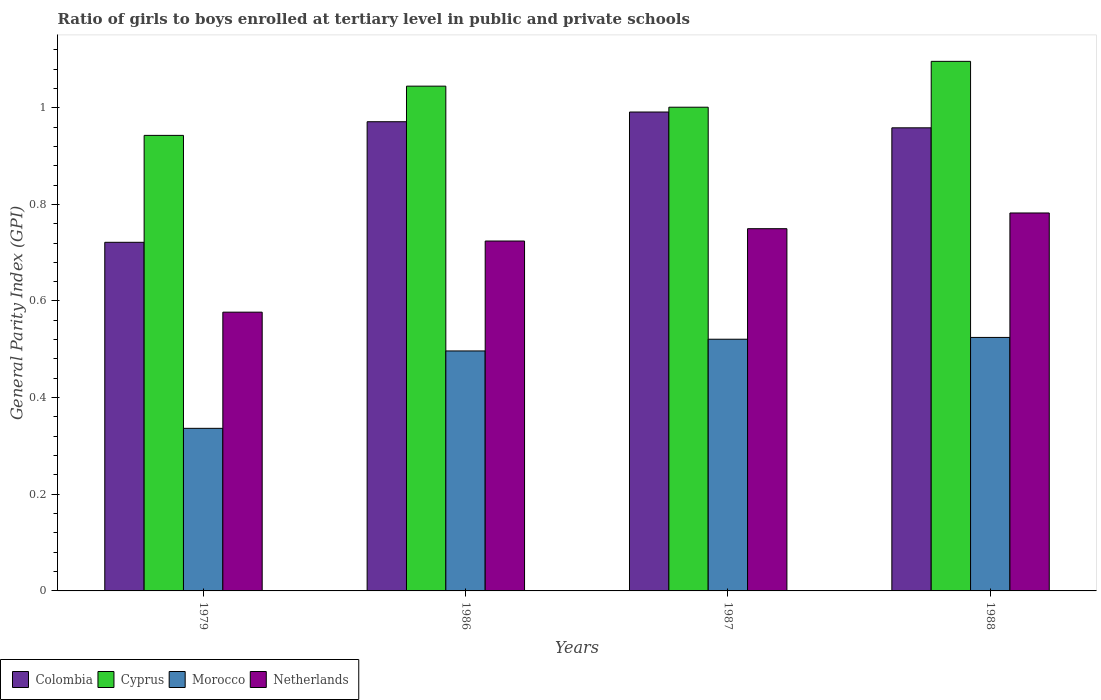How many bars are there on the 2nd tick from the left?
Provide a short and direct response. 4. How many bars are there on the 1st tick from the right?
Ensure brevity in your answer.  4. What is the general parity index in Netherlands in 1987?
Give a very brief answer. 0.75. Across all years, what is the maximum general parity index in Colombia?
Your response must be concise. 0.99. Across all years, what is the minimum general parity index in Netherlands?
Ensure brevity in your answer.  0.58. In which year was the general parity index in Colombia minimum?
Keep it short and to the point. 1979. What is the total general parity index in Cyprus in the graph?
Give a very brief answer. 4.08. What is the difference between the general parity index in Netherlands in 1987 and that in 1988?
Offer a very short reply. -0.03. What is the difference between the general parity index in Colombia in 1986 and the general parity index in Netherlands in 1987?
Keep it short and to the point. 0.22. What is the average general parity index in Morocco per year?
Offer a very short reply. 0.47. In the year 1986, what is the difference between the general parity index in Netherlands and general parity index in Cyprus?
Offer a terse response. -0.32. What is the ratio of the general parity index in Morocco in 1979 to that in 1986?
Offer a very short reply. 0.68. Is the general parity index in Morocco in 1986 less than that in 1988?
Your answer should be compact. Yes. What is the difference between the highest and the second highest general parity index in Netherlands?
Your answer should be very brief. 0.03. What is the difference between the highest and the lowest general parity index in Netherlands?
Your answer should be compact. 0.21. In how many years, is the general parity index in Netherlands greater than the average general parity index in Netherlands taken over all years?
Give a very brief answer. 3. Is the sum of the general parity index in Colombia in 1979 and 1988 greater than the maximum general parity index in Cyprus across all years?
Give a very brief answer. Yes. Is it the case that in every year, the sum of the general parity index in Morocco and general parity index in Netherlands is greater than the sum of general parity index in Colombia and general parity index in Cyprus?
Your response must be concise. No. What does the 2nd bar from the left in 1986 represents?
Your answer should be very brief. Cyprus. What does the 3rd bar from the right in 1988 represents?
Your response must be concise. Cyprus. How many bars are there?
Offer a very short reply. 16. What is the difference between two consecutive major ticks on the Y-axis?
Keep it short and to the point. 0.2. Does the graph contain grids?
Your answer should be very brief. No. How many legend labels are there?
Offer a very short reply. 4. How are the legend labels stacked?
Ensure brevity in your answer.  Horizontal. What is the title of the graph?
Your answer should be compact. Ratio of girls to boys enrolled at tertiary level in public and private schools. Does "Madagascar" appear as one of the legend labels in the graph?
Offer a very short reply. No. What is the label or title of the Y-axis?
Your answer should be very brief. General Parity Index (GPI). What is the General Parity Index (GPI) of Colombia in 1979?
Keep it short and to the point. 0.72. What is the General Parity Index (GPI) in Cyprus in 1979?
Your answer should be very brief. 0.94. What is the General Parity Index (GPI) of Morocco in 1979?
Provide a short and direct response. 0.34. What is the General Parity Index (GPI) in Netherlands in 1979?
Provide a short and direct response. 0.58. What is the General Parity Index (GPI) of Colombia in 1986?
Provide a short and direct response. 0.97. What is the General Parity Index (GPI) of Cyprus in 1986?
Provide a short and direct response. 1.04. What is the General Parity Index (GPI) of Morocco in 1986?
Provide a short and direct response. 0.5. What is the General Parity Index (GPI) in Netherlands in 1986?
Provide a succinct answer. 0.72. What is the General Parity Index (GPI) of Colombia in 1987?
Offer a very short reply. 0.99. What is the General Parity Index (GPI) of Cyprus in 1987?
Give a very brief answer. 1. What is the General Parity Index (GPI) of Morocco in 1987?
Your answer should be very brief. 0.52. What is the General Parity Index (GPI) in Netherlands in 1987?
Your answer should be very brief. 0.75. What is the General Parity Index (GPI) in Colombia in 1988?
Ensure brevity in your answer.  0.96. What is the General Parity Index (GPI) in Cyprus in 1988?
Offer a very short reply. 1.1. What is the General Parity Index (GPI) in Morocco in 1988?
Make the answer very short. 0.52. What is the General Parity Index (GPI) in Netherlands in 1988?
Your answer should be very brief. 0.78. Across all years, what is the maximum General Parity Index (GPI) in Colombia?
Make the answer very short. 0.99. Across all years, what is the maximum General Parity Index (GPI) in Cyprus?
Provide a succinct answer. 1.1. Across all years, what is the maximum General Parity Index (GPI) of Morocco?
Your response must be concise. 0.52. Across all years, what is the maximum General Parity Index (GPI) of Netherlands?
Your answer should be very brief. 0.78. Across all years, what is the minimum General Parity Index (GPI) of Colombia?
Offer a terse response. 0.72. Across all years, what is the minimum General Parity Index (GPI) of Cyprus?
Ensure brevity in your answer.  0.94. Across all years, what is the minimum General Parity Index (GPI) in Morocco?
Keep it short and to the point. 0.34. Across all years, what is the minimum General Parity Index (GPI) in Netherlands?
Your response must be concise. 0.58. What is the total General Parity Index (GPI) of Colombia in the graph?
Provide a succinct answer. 3.64. What is the total General Parity Index (GPI) of Cyprus in the graph?
Ensure brevity in your answer.  4.08. What is the total General Parity Index (GPI) of Morocco in the graph?
Your response must be concise. 1.88. What is the total General Parity Index (GPI) of Netherlands in the graph?
Provide a short and direct response. 2.83. What is the difference between the General Parity Index (GPI) of Colombia in 1979 and that in 1986?
Your response must be concise. -0.25. What is the difference between the General Parity Index (GPI) in Cyprus in 1979 and that in 1986?
Your response must be concise. -0.1. What is the difference between the General Parity Index (GPI) of Morocco in 1979 and that in 1986?
Provide a short and direct response. -0.16. What is the difference between the General Parity Index (GPI) in Netherlands in 1979 and that in 1986?
Keep it short and to the point. -0.15. What is the difference between the General Parity Index (GPI) of Colombia in 1979 and that in 1987?
Provide a short and direct response. -0.27. What is the difference between the General Parity Index (GPI) of Cyprus in 1979 and that in 1987?
Give a very brief answer. -0.06. What is the difference between the General Parity Index (GPI) of Morocco in 1979 and that in 1987?
Your answer should be compact. -0.18. What is the difference between the General Parity Index (GPI) in Netherlands in 1979 and that in 1987?
Your answer should be compact. -0.17. What is the difference between the General Parity Index (GPI) in Colombia in 1979 and that in 1988?
Your answer should be compact. -0.24. What is the difference between the General Parity Index (GPI) of Cyprus in 1979 and that in 1988?
Keep it short and to the point. -0.15. What is the difference between the General Parity Index (GPI) in Morocco in 1979 and that in 1988?
Provide a succinct answer. -0.19. What is the difference between the General Parity Index (GPI) in Netherlands in 1979 and that in 1988?
Your answer should be compact. -0.21. What is the difference between the General Parity Index (GPI) of Colombia in 1986 and that in 1987?
Ensure brevity in your answer.  -0.02. What is the difference between the General Parity Index (GPI) of Cyprus in 1986 and that in 1987?
Give a very brief answer. 0.04. What is the difference between the General Parity Index (GPI) in Morocco in 1986 and that in 1987?
Provide a short and direct response. -0.02. What is the difference between the General Parity Index (GPI) of Netherlands in 1986 and that in 1987?
Make the answer very short. -0.03. What is the difference between the General Parity Index (GPI) of Colombia in 1986 and that in 1988?
Provide a succinct answer. 0.01. What is the difference between the General Parity Index (GPI) of Cyprus in 1986 and that in 1988?
Offer a very short reply. -0.05. What is the difference between the General Parity Index (GPI) in Morocco in 1986 and that in 1988?
Provide a short and direct response. -0.03. What is the difference between the General Parity Index (GPI) of Netherlands in 1986 and that in 1988?
Give a very brief answer. -0.06. What is the difference between the General Parity Index (GPI) of Colombia in 1987 and that in 1988?
Make the answer very short. 0.03. What is the difference between the General Parity Index (GPI) in Cyprus in 1987 and that in 1988?
Provide a succinct answer. -0.09. What is the difference between the General Parity Index (GPI) in Morocco in 1987 and that in 1988?
Your response must be concise. -0. What is the difference between the General Parity Index (GPI) of Netherlands in 1987 and that in 1988?
Give a very brief answer. -0.03. What is the difference between the General Parity Index (GPI) of Colombia in 1979 and the General Parity Index (GPI) of Cyprus in 1986?
Keep it short and to the point. -0.32. What is the difference between the General Parity Index (GPI) in Colombia in 1979 and the General Parity Index (GPI) in Morocco in 1986?
Your answer should be very brief. 0.22. What is the difference between the General Parity Index (GPI) in Colombia in 1979 and the General Parity Index (GPI) in Netherlands in 1986?
Your answer should be very brief. -0. What is the difference between the General Parity Index (GPI) in Cyprus in 1979 and the General Parity Index (GPI) in Morocco in 1986?
Provide a short and direct response. 0.45. What is the difference between the General Parity Index (GPI) of Cyprus in 1979 and the General Parity Index (GPI) of Netherlands in 1986?
Give a very brief answer. 0.22. What is the difference between the General Parity Index (GPI) of Morocco in 1979 and the General Parity Index (GPI) of Netherlands in 1986?
Offer a terse response. -0.39. What is the difference between the General Parity Index (GPI) in Colombia in 1979 and the General Parity Index (GPI) in Cyprus in 1987?
Your answer should be compact. -0.28. What is the difference between the General Parity Index (GPI) in Colombia in 1979 and the General Parity Index (GPI) in Morocco in 1987?
Your response must be concise. 0.2. What is the difference between the General Parity Index (GPI) in Colombia in 1979 and the General Parity Index (GPI) in Netherlands in 1987?
Make the answer very short. -0.03. What is the difference between the General Parity Index (GPI) in Cyprus in 1979 and the General Parity Index (GPI) in Morocco in 1987?
Give a very brief answer. 0.42. What is the difference between the General Parity Index (GPI) of Cyprus in 1979 and the General Parity Index (GPI) of Netherlands in 1987?
Provide a short and direct response. 0.19. What is the difference between the General Parity Index (GPI) in Morocco in 1979 and the General Parity Index (GPI) in Netherlands in 1987?
Your answer should be compact. -0.41. What is the difference between the General Parity Index (GPI) of Colombia in 1979 and the General Parity Index (GPI) of Cyprus in 1988?
Your response must be concise. -0.37. What is the difference between the General Parity Index (GPI) of Colombia in 1979 and the General Parity Index (GPI) of Morocco in 1988?
Give a very brief answer. 0.2. What is the difference between the General Parity Index (GPI) of Colombia in 1979 and the General Parity Index (GPI) of Netherlands in 1988?
Make the answer very short. -0.06. What is the difference between the General Parity Index (GPI) of Cyprus in 1979 and the General Parity Index (GPI) of Morocco in 1988?
Make the answer very short. 0.42. What is the difference between the General Parity Index (GPI) of Cyprus in 1979 and the General Parity Index (GPI) of Netherlands in 1988?
Your response must be concise. 0.16. What is the difference between the General Parity Index (GPI) of Morocco in 1979 and the General Parity Index (GPI) of Netherlands in 1988?
Your response must be concise. -0.45. What is the difference between the General Parity Index (GPI) of Colombia in 1986 and the General Parity Index (GPI) of Cyprus in 1987?
Provide a short and direct response. -0.03. What is the difference between the General Parity Index (GPI) in Colombia in 1986 and the General Parity Index (GPI) in Morocco in 1987?
Keep it short and to the point. 0.45. What is the difference between the General Parity Index (GPI) in Colombia in 1986 and the General Parity Index (GPI) in Netherlands in 1987?
Provide a short and direct response. 0.22. What is the difference between the General Parity Index (GPI) in Cyprus in 1986 and the General Parity Index (GPI) in Morocco in 1987?
Your answer should be compact. 0.52. What is the difference between the General Parity Index (GPI) in Cyprus in 1986 and the General Parity Index (GPI) in Netherlands in 1987?
Offer a very short reply. 0.29. What is the difference between the General Parity Index (GPI) of Morocco in 1986 and the General Parity Index (GPI) of Netherlands in 1987?
Your answer should be very brief. -0.25. What is the difference between the General Parity Index (GPI) of Colombia in 1986 and the General Parity Index (GPI) of Cyprus in 1988?
Ensure brevity in your answer.  -0.12. What is the difference between the General Parity Index (GPI) of Colombia in 1986 and the General Parity Index (GPI) of Morocco in 1988?
Provide a short and direct response. 0.45. What is the difference between the General Parity Index (GPI) in Colombia in 1986 and the General Parity Index (GPI) in Netherlands in 1988?
Make the answer very short. 0.19. What is the difference between the General Parity Index (GPI) in Cyprus in 1986 and the General Parity Index (GPI) in Morocco in 1988?
Offer a very short reply. 0.52. What is the difference between the General Parity Index (GPI) in Cyprus in 1986 and the General Parity Index (GPI) in Netherlands in 1988?
Offer a very short reply. 0.26. What is the difference between the General Parity Index (GPI) in Morocco in 1986 and the General Parity Index (GPI) in Netherlands in 1988?
Provide a short and direct response. -0.29. What is the difference between the General Parity Index (GPI) in Colombia in 1987 and the General Parity Index (GPI) in Cyprus in 1988?
Give a very brief answer. -0.1. What is the difference between the General Parity Index (GPI) of Colombia in 1987 and the General Parity Index (GPI) of Morocco in 1988?
Provide a short and direct response. 0.47. What is the difference between the General Parity Index (GPI) in Colombia in 1987 and the General Parity Index (GPI) in Netherlands in 1988?
Offer a very short reply. 0.21. What is the difference between the General Parity Index (GPI) in Cyprus in 1987 and the General Parity Index (GPI) in Morocco in 1988?
Your response must be concise. 0.48. What is the difference between the General Parity Index (GPI) in Cyprus in 1987 and the General Parity Index (GPI) in Netherlands in 1988?
Your answer should be compact. 0.22. What is the difference between the General Parity Index (GPI) in Morocco in 1987 and the General Parity Index (GPI) in Netherlands in 1988?
Offer a very short reply. -0.26. What is the average General Parity Index (GPI) in Colombia per year?
Your response must be concise. 0.91. What is the average General Parity Index (GPI) in Cyprus per year?
Your answer should be very brief. 1.02. What is the average General Parity Index (GPI) in Morocco per year?
Provide a succinct answer. 0.47. What is the average General Parity Index (GPI) in Netherlands per year?
Provide a short and direct response. 0.71. In the year 1979, what is the difference between the General Parity Index (GPI) of Colombia and General Parity Index (GPI) of Cyprus?
Ensure brevity in your answer.  -0.22. In the year 1979, what is the difference between the General Parity Index (GPI) of Colombia and General Parity Index (GPI) of Morocco?
Keep it short and to the point. 0.39. In the year 1979, what is the difference between the General Parity Index (GPI) in Colombia and General Parity Index (GPI) in Netherlands?
Provide a short and direct response. 0.14. In the year 1979, what is the difference between the General Parity Index (GPI) of Cyprus and General Parity Index (GPI) of Morocco?
Provide a succinct answer. 0.61. In the year 1979, what is the difference between the General Parity Index (GPI) of Cyprus and General Parity Index (GPI) of Netherlands?
Offer a very short reply. 0.37. In the year 1979, what is the difference between the General Parity Index (GPI) in Morocco and General Parity Index (GPI) in Netherlands?
Give a very brief answer. -0.24. In the year 1986, what is the difference between the General Parity Index (GPI) of Colombia and General Parity Index (GPI) of Cyprus?
Give a very brief answer. -0.07. In the year 1986, what is the difference between the General Parity Index (GPI) of Colombia and General Parity Index (GPI) of Morocco?
Ensure brevity in your answer.  0.47. In the year 1986, what is the difference between the General Parity Index (GPI) in Colombia and General Parity Index (GPI) in Netherlands?
Give a very brief answer. 0.25. In the year 1986, what is the difference between the General Parity Index (GPI) of Cyprus and General Parity Index (GPI) of Morocco?
Your answer should be compact. 0.55. In the year 1986, what is the difference between the General Parity Index (GPI) in Cyprus and General Parity Index (GPI) in Netherlands?
Keep it short and to the point. 0.32. In the year 1986, what is the difference between the General Parity Index (GPI) of Morocco and General Parity Index (GPI) of Netherlands?
Provide a short and direct response. -0.23. In the year 1987, what is the difference between the General Parity Index (GPI) in Colombia and General Parity Index (GPI) in Cyprus?
Offer a terse response. -0.01. In the year 1987, what is the difference between the General Parity Index (GPI) in Colombia and General Parity Index (GPI) in Morocco?
Keep it short and to the point. 0.47. In the year 1987, what is the difference between the General Parity Index (GPI) in Colombia and General Parity Index (GPI) in Netherlands?
Provide a succinct answer. 0.24. In the year 1987, what is the difference between the General Parity Index (GPI) of Cyprus and General Parity Index (GPI) of Morocco?
Offer a terse response. 0.48. In the year 1987, what is the difference between the General Parity Index (GPI) in Cyprus and General Parity Index (GPI) in Netherlands?
Your answer should be compact. 0.25. In the year 1987, what is the difference between the General Parity Index (GPI) in Morocco and General Parity Index (GPI) in Netherlands?
Ensure brevity in your answer.  -0.23. In the year 1988, what is the difference between the General Parity Index (GPI) in Colombia and General Parity Index (GPI) in Cyprus?
Give a very brief answer. -0.14. In the year 1988, what is the difference between the General Parity Index (GPI) in Colombia and General Parity Index (GPI) in Morocco?
Offer a terse response. 0.43. In the year 1988, what is the difference between the General Parity Index (GPI) in Colombia and General Parity Index (GPI) in Netherlands?
Keep it short and to the point. 0.18. In the year 1988, what is the difference between the General Parity Index (GPI) of Cyprus and General Parity Index (GPI) of Morocco?
Give a very brief answer. 0.57. In the year 1988, what is the difference between the General Parity Index (GPI) of Cyprus and General Parity Index (GPI) of Netherlands?
Give a very brief answer. 0.31. In the year 1988, what is the difference between the General Parity Index (GPI) of Morocco and General Parity Index (GPI) of Netherlands?
Give a very brief answer. -0.26. What is the ratio of the General Parity Index (GPI) of Colombia in 1979 to that in 1986?
Offer a very short reply. 0.74. What is the ratio of the General Parity Index (GPI) of Cyprus in 1979 to that in 1986?
Your response must be concise. 0.9. What is the ratio of the General Parity Index (GPI) in Morocco in 1979 to that in 1986?
Offer a terse response. 0.68. What is the ratio of the General Parity Index (GPI) of Netherlands in 1979 to that in 1986?
Make the answer very short. 0.8. What is the ratio of the General Parity Index (GPI) of Colombia in 1979 to that in 1987?
Your answer should be very brief. 0.73. What is the ratio of the General Parity Index (GPI) in Cyprus in 1979 to that in 1987?
Your answer should be compact. 0.94. What is the ratio of the General Parity Index (GPI) in Morocco in 1979 to that in 1987?
Ensure brevity in your answer.  0.65. What is the ratio of the General Parity Index (GPI) of Netherlands in 1979 to that in 1987?
Your answer should be compact. 0.77. What is the ratio of the General Parity Index (GPI) of Colombia in 1979 to that in 1988?
Ensure brevity in your answer.  0.75. What is the ratio of the General Parity Index (GPI) in Cyprus in 1979 to that in 1988?
Offer a terse response. 0.86. What is the ratio of the General Parity Index (GPI) of Morocco in 1979 to that in 1988?
Make the answer very short. 0.64. What is the ratio of the General Parity Index (GPI) in Netherlands in 1979 to that in 1988?
Keep it short and to the point. 0.74. What is the ratio of the General Parity Index (GPI) in Colombia in 1986 to that in 1987?
Offer a very short reply. 0.98. What is the ratio of the General Parity Index (GPI) of Cyprus in 1986 to that in 1987?
Give a very brief answer. 1.04. What is the ratio of the General Parity Index (GPI) of Morocco in 1986 to that in 1987?
Provide a short and direct response. 0.95. What is the ratio of the General Parity Index (GPI) in Netherlands in 1986 to that in 1987?
Your answer should be compact. 0.97. What is the ratio of the General Parity Index (GPI) in Colombia in 1986 to that in 1988?
Your answer should be very brief. 1.01. What is the ratio of the General Parity Index (GPI) of Cyprus in 1986 to that in 1988?
Make the answer very short. 0.95. What is the ratio of the General Parity Index (GPI) in Morocco in 1986 to that in 1988?
Offer a very short reply. 0.95. What is the ratio of the General Parity Index (GPI) of Netherlands in 1986 to that in 1988?
Offer a terse response. 0.93. What is the ratio of the General Parity Index (GPI) in Colombia in 1987 to that in 1988?
Your answer should be very brief. 1.03. What is the ratio of the General Parity Index (GPI) of Cyprus in 1987 to that in 1988?
Offer a very short reply. 0.91. What is the ratio of the General Parity Index (GPI) of Netherlands in 1987 to that in 1988?
Offer a very short reply. 0.96. What is the difference between the highest and the second highest General Parity Index (GPI) of Colombia?
Make the answer very short. 0.02. What is the difference between the highest and the second highest General Parity Index (GPI) in Cyprus?
Offer a terse response. 0.05. What is the difference between the highest and the second highest General Parity Index (GPI) in Morocco?
Make the answer very short. 0. What is the difference between the highest and the second highest General Parity Index (GPI) of Netherlands?
Ensure brevity in your answer.  0.03. What is the difference between the highest and the lowest General Parity Index (GPI) of Colombia?
Provide a succinct answer. 0.27. What is the difference between the highest and the lowest General Parity Index (GPI) of Cyprus?
Give a very brief answer. 0.15. What is the difference between the highest and the lowest General Parity Index (GPI) of Morocco?
Your answer should be very brief. 0.19. What is the difference between the highest and the lowest General Parity Index (GPI) in Netherlands?
Your response must be concise. 0.21. 